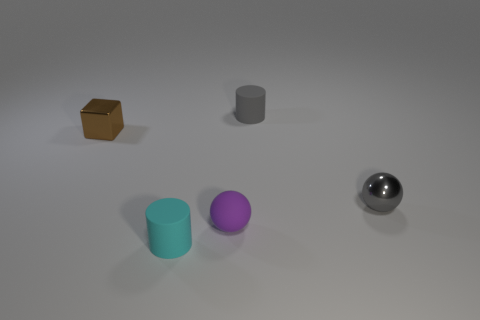What number of small objects have the same color as the tiny shiny sphere?
Offer a terse response. 1. What number of objects are metal balls right of the small brown metal thing or blue blocks?
Your response must be concise. 1. Is the number of large cyan shiny blocks less than the number of gray cylinders?
Your answer should be very brief. Yes. Is the material of the gray thing that is behind the cube the same as the tiny gray thing in front of the brown cube?
Give a very brief answer. No. The tiny metallic object on the right side of the tiny cylinder that is in front of the small sphere to the left of the small metallic ball is what shape?
Offer a terse response. Sphere. What number of small cyan things have the same material as the cyan cylinder?
Your answer should be very brief. 0. There is a thing left of the tiny cyan rubber cylinder; what number of gray things are behind it?
Provide a short and direct response. 1. Is the color of the tiny rubber cylinder that is behind the tiny purple ball the same as the metal thing that is to the right of the tiny cyan rubber cylinder?
Your answer should be very brief. Yes. There is a thing that is both behind the small purple object and in front of the tiny brown metallic object; what shape is it?
Provide a short and direct response. Sphere. Is there a small gray matte object that has the same shape as the tiny cyan object?
Your answer should be compact. Yes. 